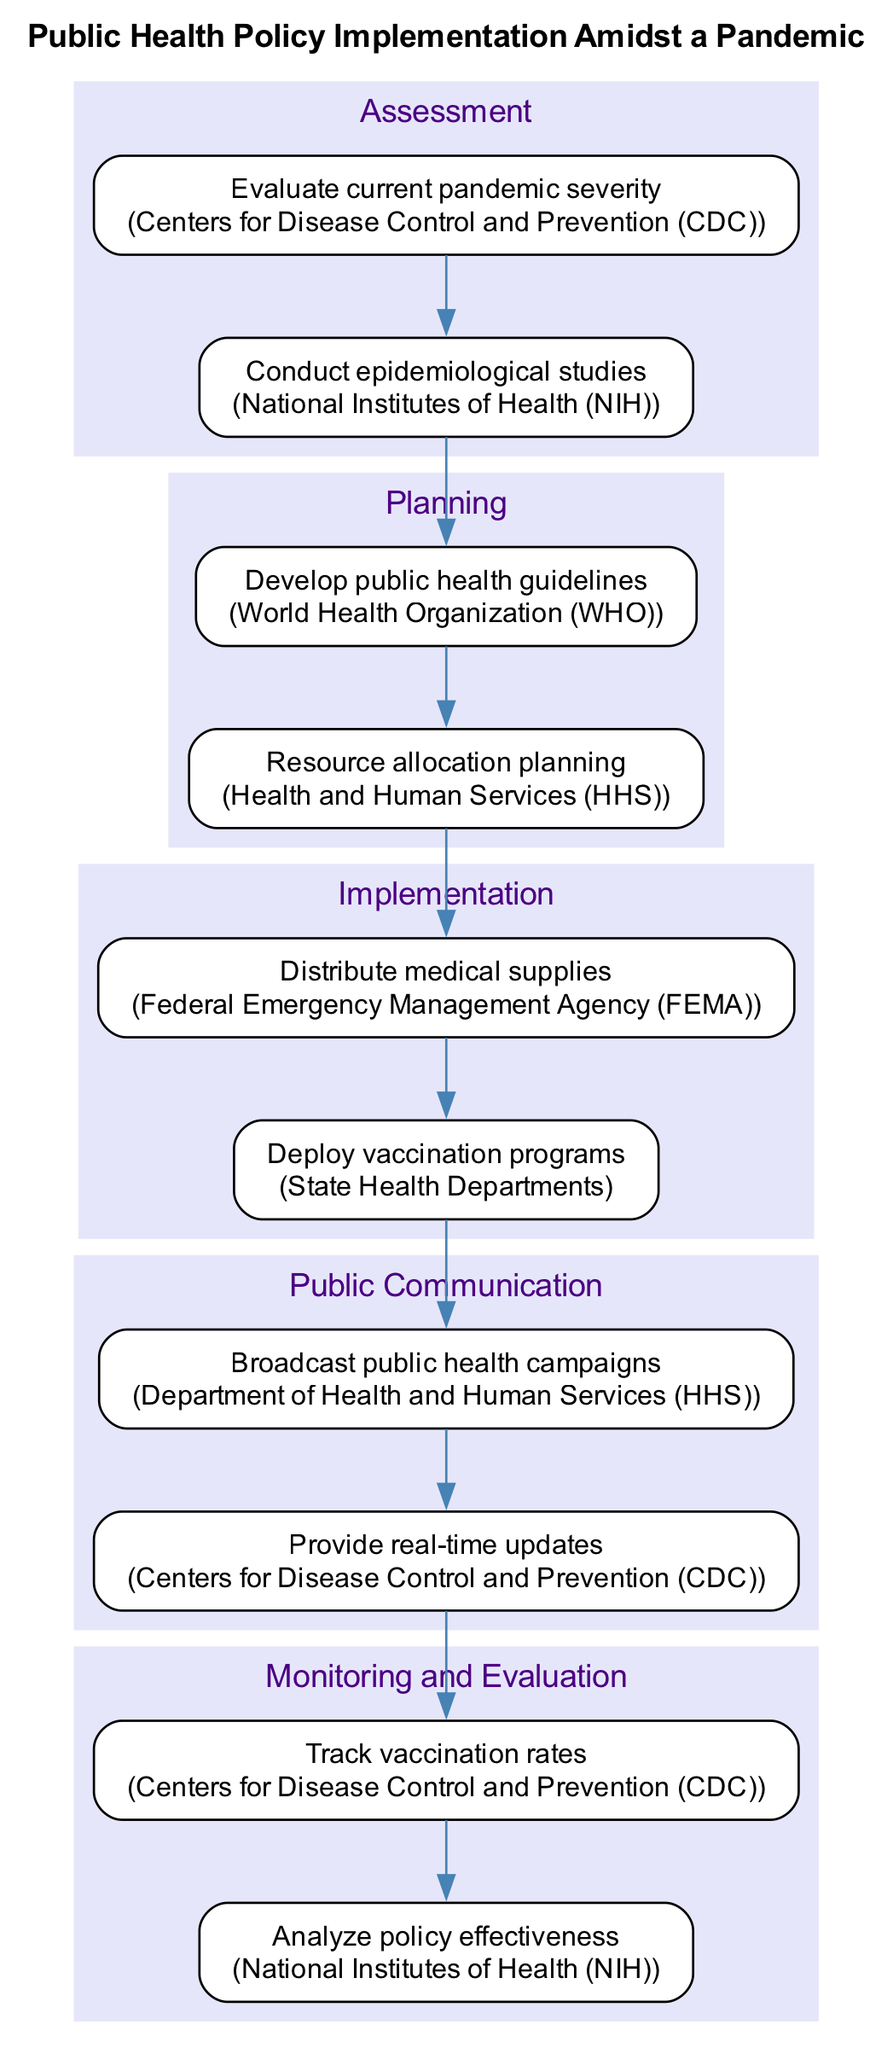What is the first stage of the clinical pathway? The first stage indicated in the diagram is "Assessment," which includes actions to evaluate current pandemic severity and conduct epidemiological studies.
Answer: Assessment How many actions are listed under the "Planning" stage? In the "Planning" stage, there are two actions: developing public health guidelines and resource allocation planning.
Answer: 2 Which organization is responsible for real-time updates? The organization responsible for providing real-time updates is the Centers for Disease Control and Prevention (CDC), as indicated in the "Public Communication" stage.
Answer: Centers for Disease Control and Prevention (CDC) What follows the "Implementation" stage in the diagram? After the "Implementation" stage, the next stage indicated in the diagram is "Public Communication." This follows the actions of distributing medical supplies and deploying vaccination programs.
Answer: Public Communication How many total stages are outlined in the clinical pathway diagram? The clinical pathway diagram outlines a total of five stages: Assessment, Planning, Implementation, Public Communication, and Monitoring and Evaluation.
Answer: 5 What is the last action listed in the clinical pathway? The last action listed in the clinical pathway is "Analyze policy effectiveness," which is under the "Monitoring and Evaluation" stage.
Answer: Analyze policy effectiveness Which responsibility is shared between the CDC and NIH in the pathway? Both the Centers for Disease Control and Prevention (CDC) and the National Institutes of Health (NIH) have responsibilities related to monitoring and evaluation; specifically, to evaluate pandemic severity and analyze policy effectiveness.
Answer: Evaluate pandemic severity, Analyze policy effectiveness What type of information does the "Public Communication" stage focus on? The "Public Communication" stage focuses on broadcasting public health campaigns and providing real-time updates to the public about the ongoing situation related to the pandemic.
Answer: Broadcasting public health campaigns, Providing real-time updates 